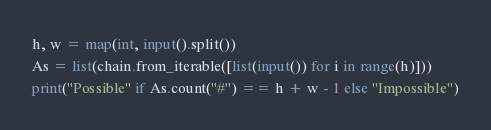<code> <loc_0><loc_0><loc_500><loc_500><_Python_>h, w = map(int, input().split())
As = list(chain.from_iterable([list(input()) for i in range(h)]))
print("Possible" if As.count("#") == h + w - 1 else "Impossible")</code> 